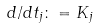Convert formula to latex. <formula><loc_0><loc_0><loc_500><loc_500>d / d t _ { j } \colon = K _ { j }</formula> 